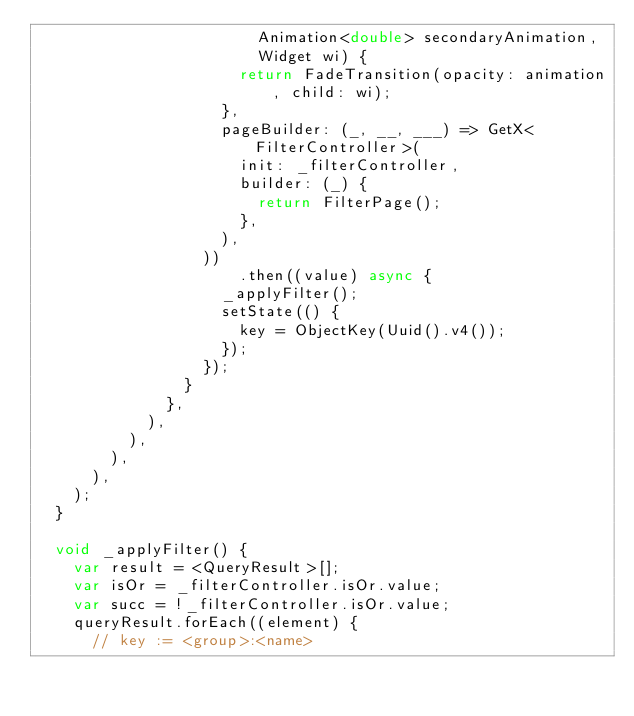Convert code to text. <code><loc_0><loc_0><loc_500><loc_500><_Dart_>                        Animation<double> secondaryAnimation,
                        Widget wi) {
                      return FadeTransition(opacity: animation, child: wi);
                    },
                    pageBuilder: (_, __, ___) => GetX<FilterController>(
                      init: _filterController,
                      builder: (_) {
                        return FilterPage();
                      },
                    ),
                  ))
                      .then((value) async {
                    _applyFilter();
                    setState(() {
                      key = ObjectKey(Uuid().v4());
                    });
                  });
                }
              },
            ),
          ),
        ),
      ),
    );
  }

  void _applyFilter() {
    var result = <QueryResult>[];
    var isOr = _filterController.isOr.value;
    var succ = !_filterController.isOr.value;
    queryResult.forEach((element) {
      // key := <group>:<name></code> 